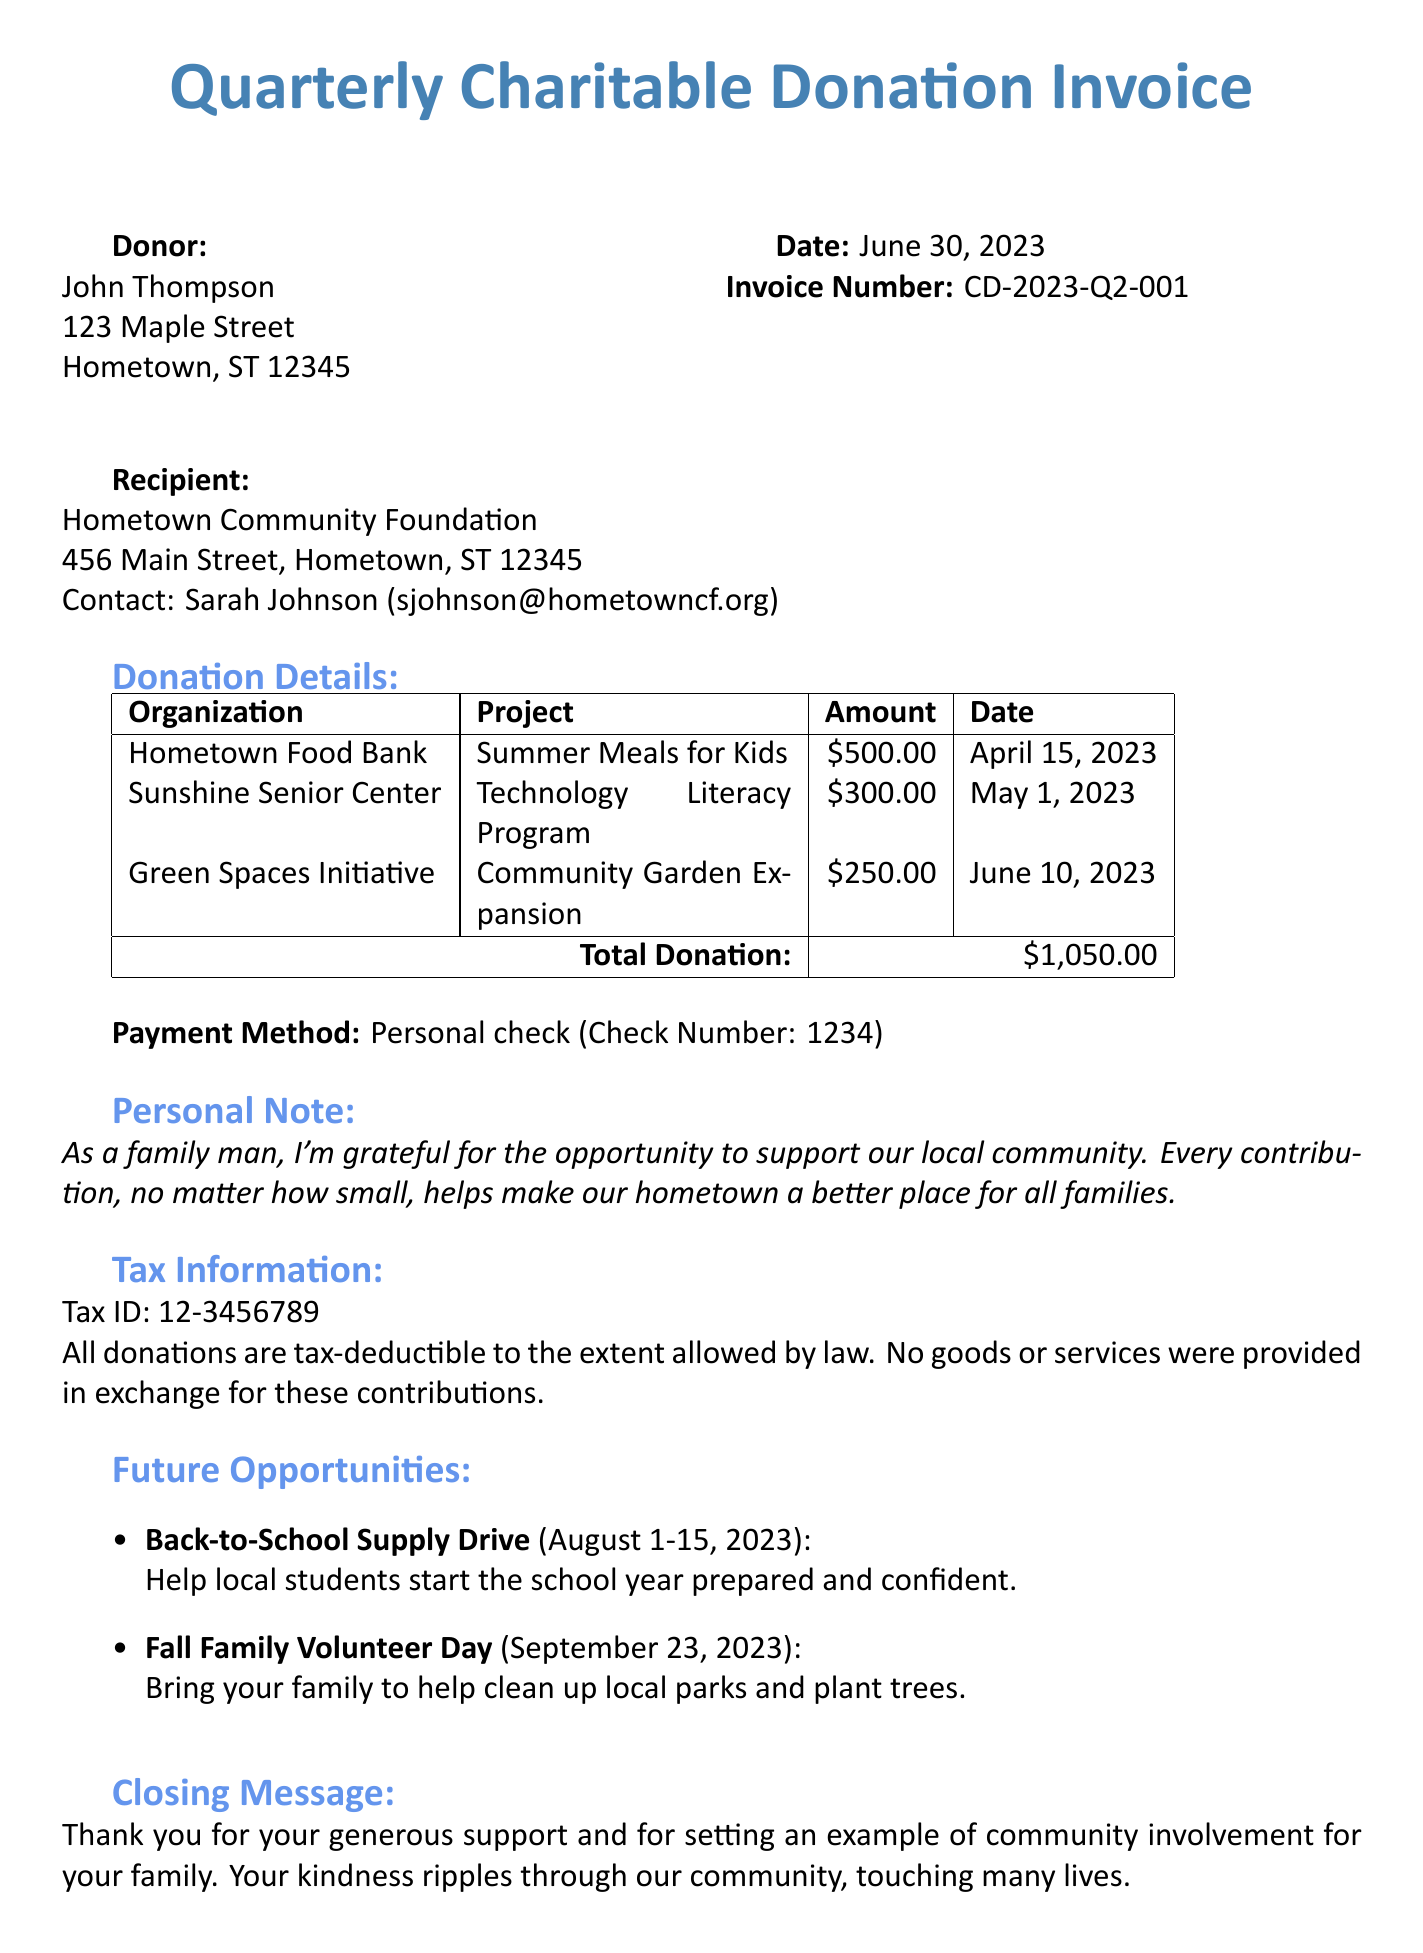What is the title of the document? The title is prominently displayed at the top of the document and is "Quarterly Charitable Donation Invoice."
Answer: Quarterly Charitable Donation Invoice Who is the donor? The name of the donor is shown in the invoice header.
Answer: John Thompson What is the total donation amount? The total donation is calculated based on the individual donations listed in the document, summing them up gives $1050.00.
Answer: $1,050.00 What is the payment method? The payment method is explicitly stated in the document.
Answer: Personal check When was the donation made to Green Spaces Initiative? The date of the donation to Green Spaces Initiative is specified in the donation details.
Answer: June 10, 2023 Which organization received the largest donation? By comparing the amounts in the donation details, the largest amount is associated with Hometown Food Bank.
Answer: Hometown Food Bank What is the purpose of the Back-to-School Supply Drive? The document describes the event and its goals in the future opportunities section.
Answer: Help local students start the school year prepared and confident What is the tax ID number? The tax ID number can be found under the tax information section of the document.
Answer: 12-3456789 What is the personal note about? The personal note reflects the donor's appreciation for the opportunity to contribute to the community.
Answer: Grateful for the opportunity to support our local community 